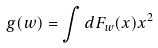<formula> <loc_0><loc_0><loc_500><loc_500>g ( w ) = \int d F _ { w } ( x ) x ^ { 2 }</formula> 